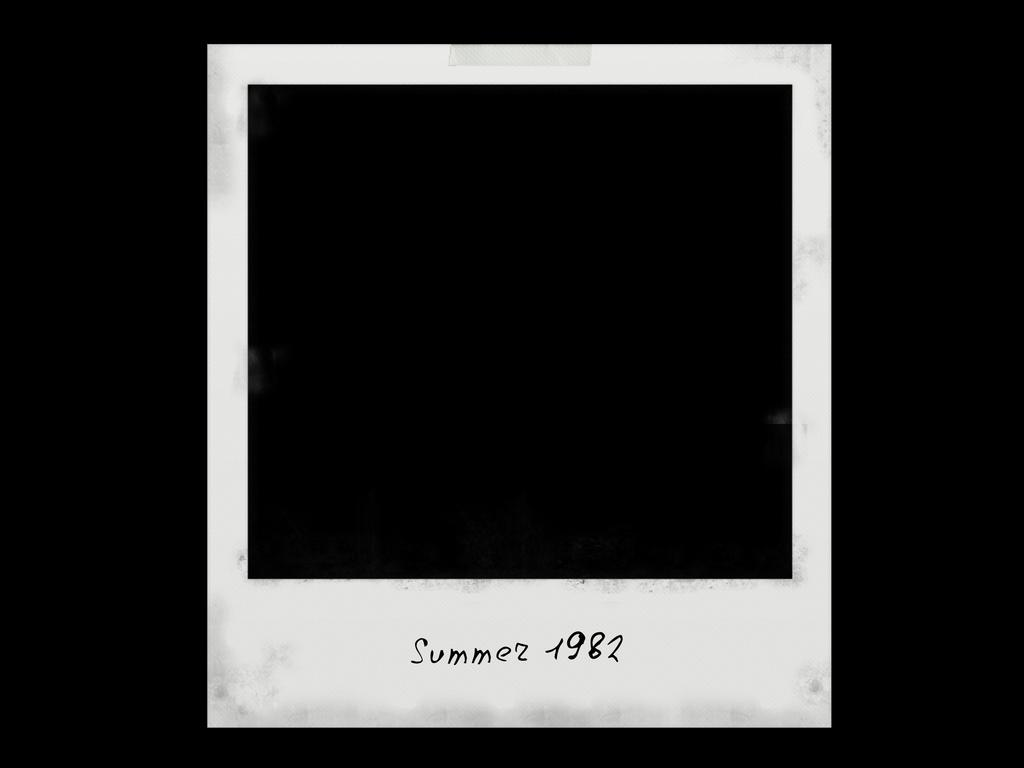<image>
Render a clear and concise summary of the photo. A polaroid photo shows a completely black image with the written caption "Summer 1982." 